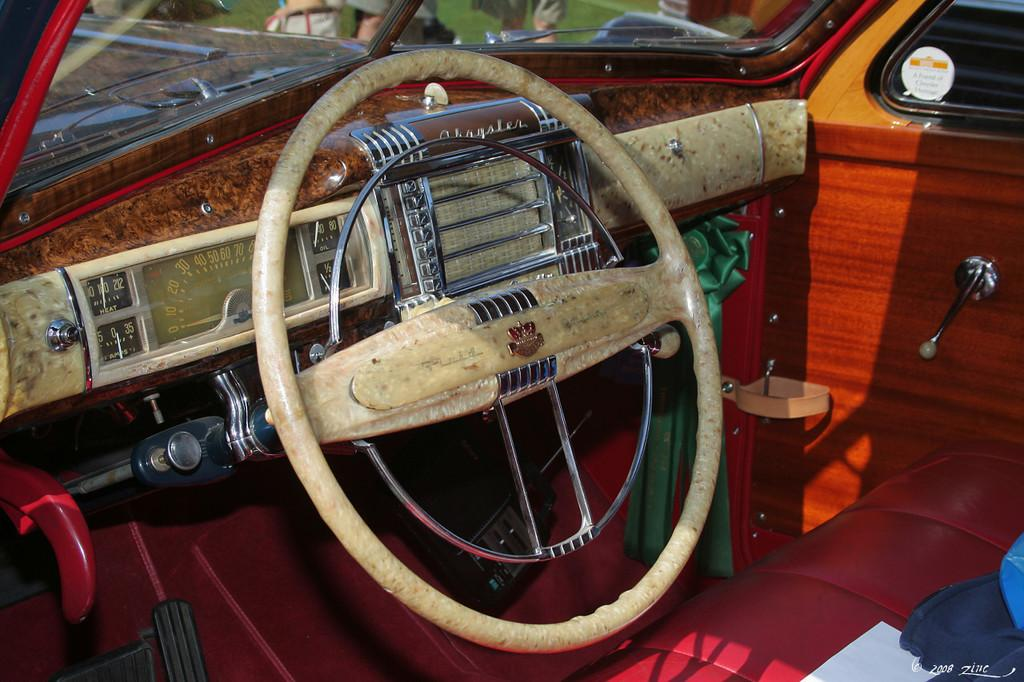What type of setting is depicted in the image? The image shows the interior of a motor vehicle. Can you describe any specific features or objects within the motor vehicle? Unfortunately, the provided facts do not include any specific details about the interior of the motor vehicle. What type of drink is being served in the image? There is no drink present in the image, as it shows the interior of a motor vehicle. 